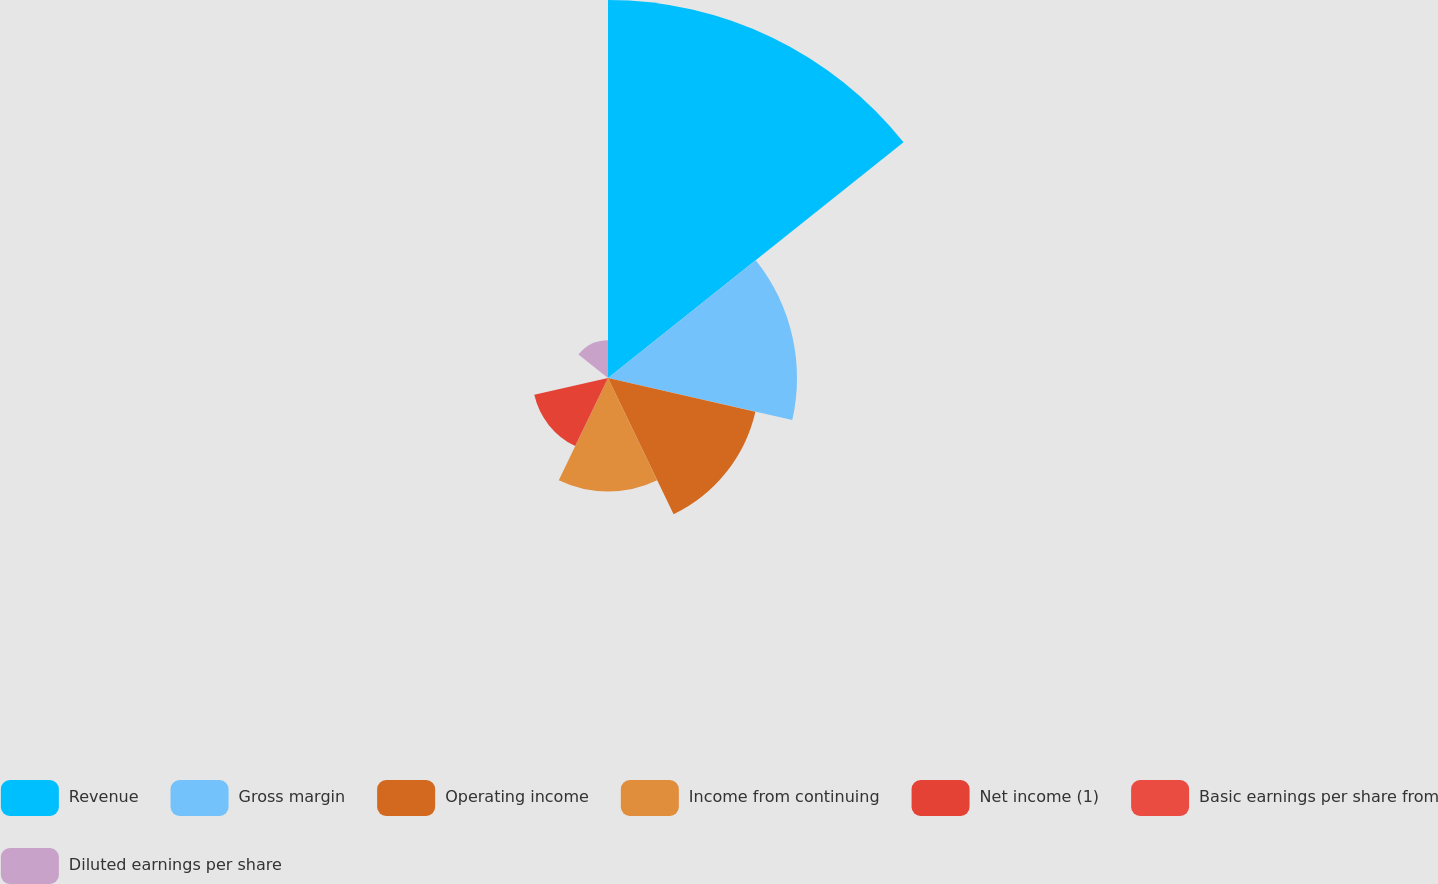Convert chart to OTSL. <chart><loc_0><loc_0><loc_500><loc_500><pie_chart><fcel>Revenue<fcel>Gross margin<fcel>Operating income<fcel>Income from continuing<fcel>Net income (1)<fcel>Basic earnings per share from<fcel>Diluted earnings per share<nl><fcel>40.0%<fcel>20.0%<fcel>16.0%<fcel>12.0%<fcel>8.0%<fcel>0.0%<fcel>4.0%<nl></chart> 